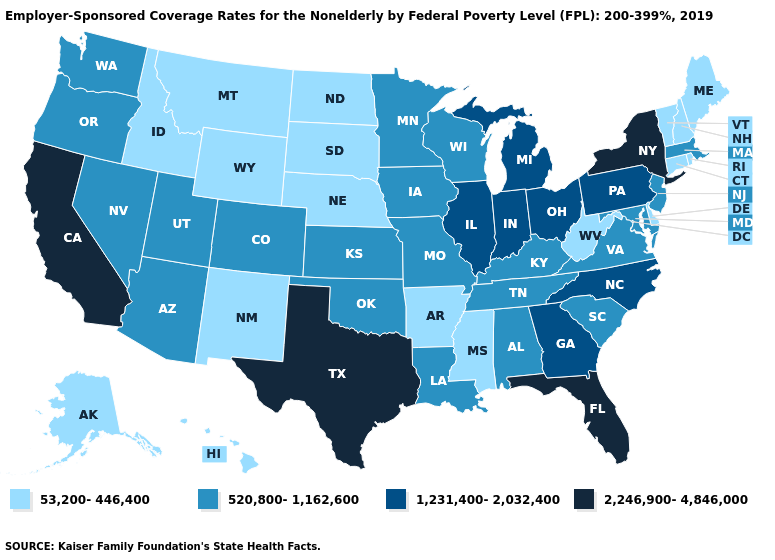What is the value of North Carolina?
Short answer required. 1,231,400-2,032,400. Does the map have missing data?
Short answer required. No. Name the states that have a value in the range 53,200-446,400?
Quick response, please. Alaska, Arkansas, Connecticut, Delaware, Hawaii, Idaho, Maine, Mississippi, Montana, Nebraska, New Hampshire, New Mexico, North Dakota, Rhode Island, South Dakota, Vermont, West Virginia, Wyoming. What is the value of Iowa?
Give a very brief answer. 520,800-1,162,600. Which states hav the highest value in the Northeast?
Give a very brief answer. New York. What is the value of Hawaii?
Be succinct. 53,200-446,400. What is the value of Louisiana?
Answer briefly. 520,800-1,162,600. What is the highest value in the USA?
Quick response, please. 2,246,900-4,846,000. What is the value of Oregon?
Keep it brief. 520,800-1,162,600. What is the value of Indiana?
Be succinct. 1,231,400-2,032,400. What is the value of Michigan?
Quick response, please. 1,231,400-2,032,400. Does Kansas have the same value as Louisiana?
Be succinct. Yes. What is the highest value in the USA?
Short answer required. 2,246,900-4,846,000. What is the highest value in the USA?
Keep it brief. 2,246,900-4,846,000. 